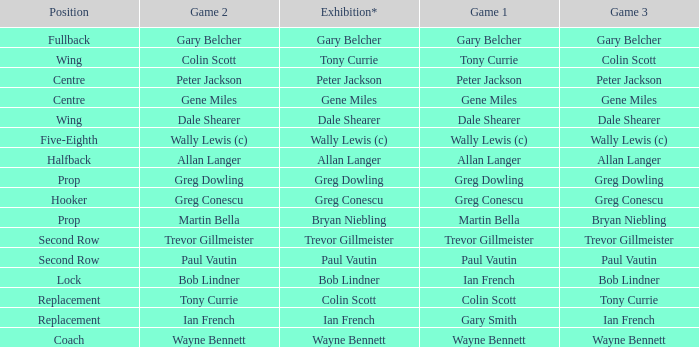What game 1 has bob lindner as game 2? Ian French. 